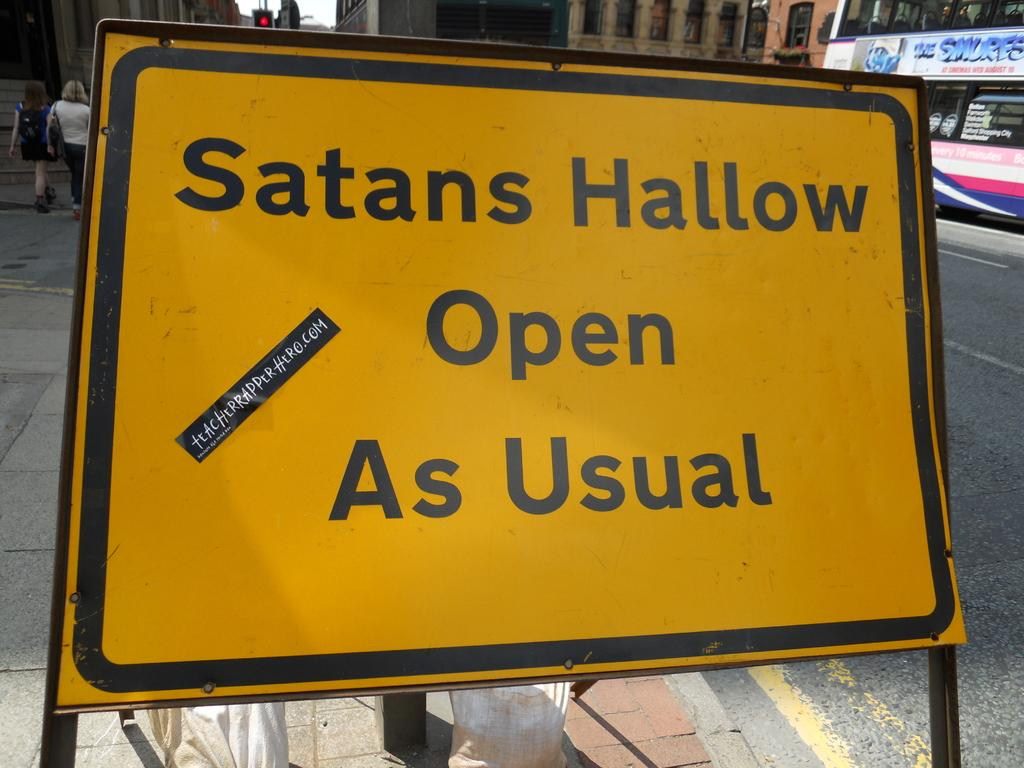<image>
Describe the image concisely. A yellow sign board on the edge of a sidewalk reads "Satans Hallow Open as Usual". 